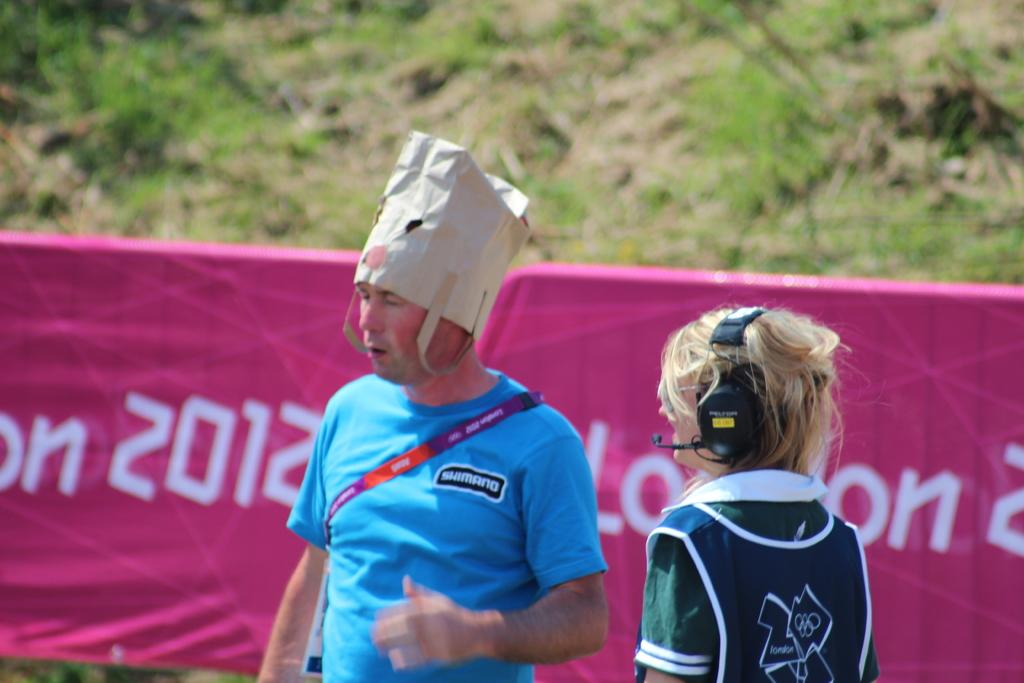Provide a one-sentence caption for the provided image. The year 2012 is on a pink banner behind people. 